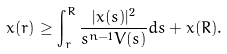<formula> <loc_0><loc_0><loc_500><loc_500>x ( r ) \geq \int _ { r } ^ { R } \frac { | x ( s ) | ^ { 2 } } { s ^ { n - 1 } V ( s ) } d s + x ( R ) .</formula> 